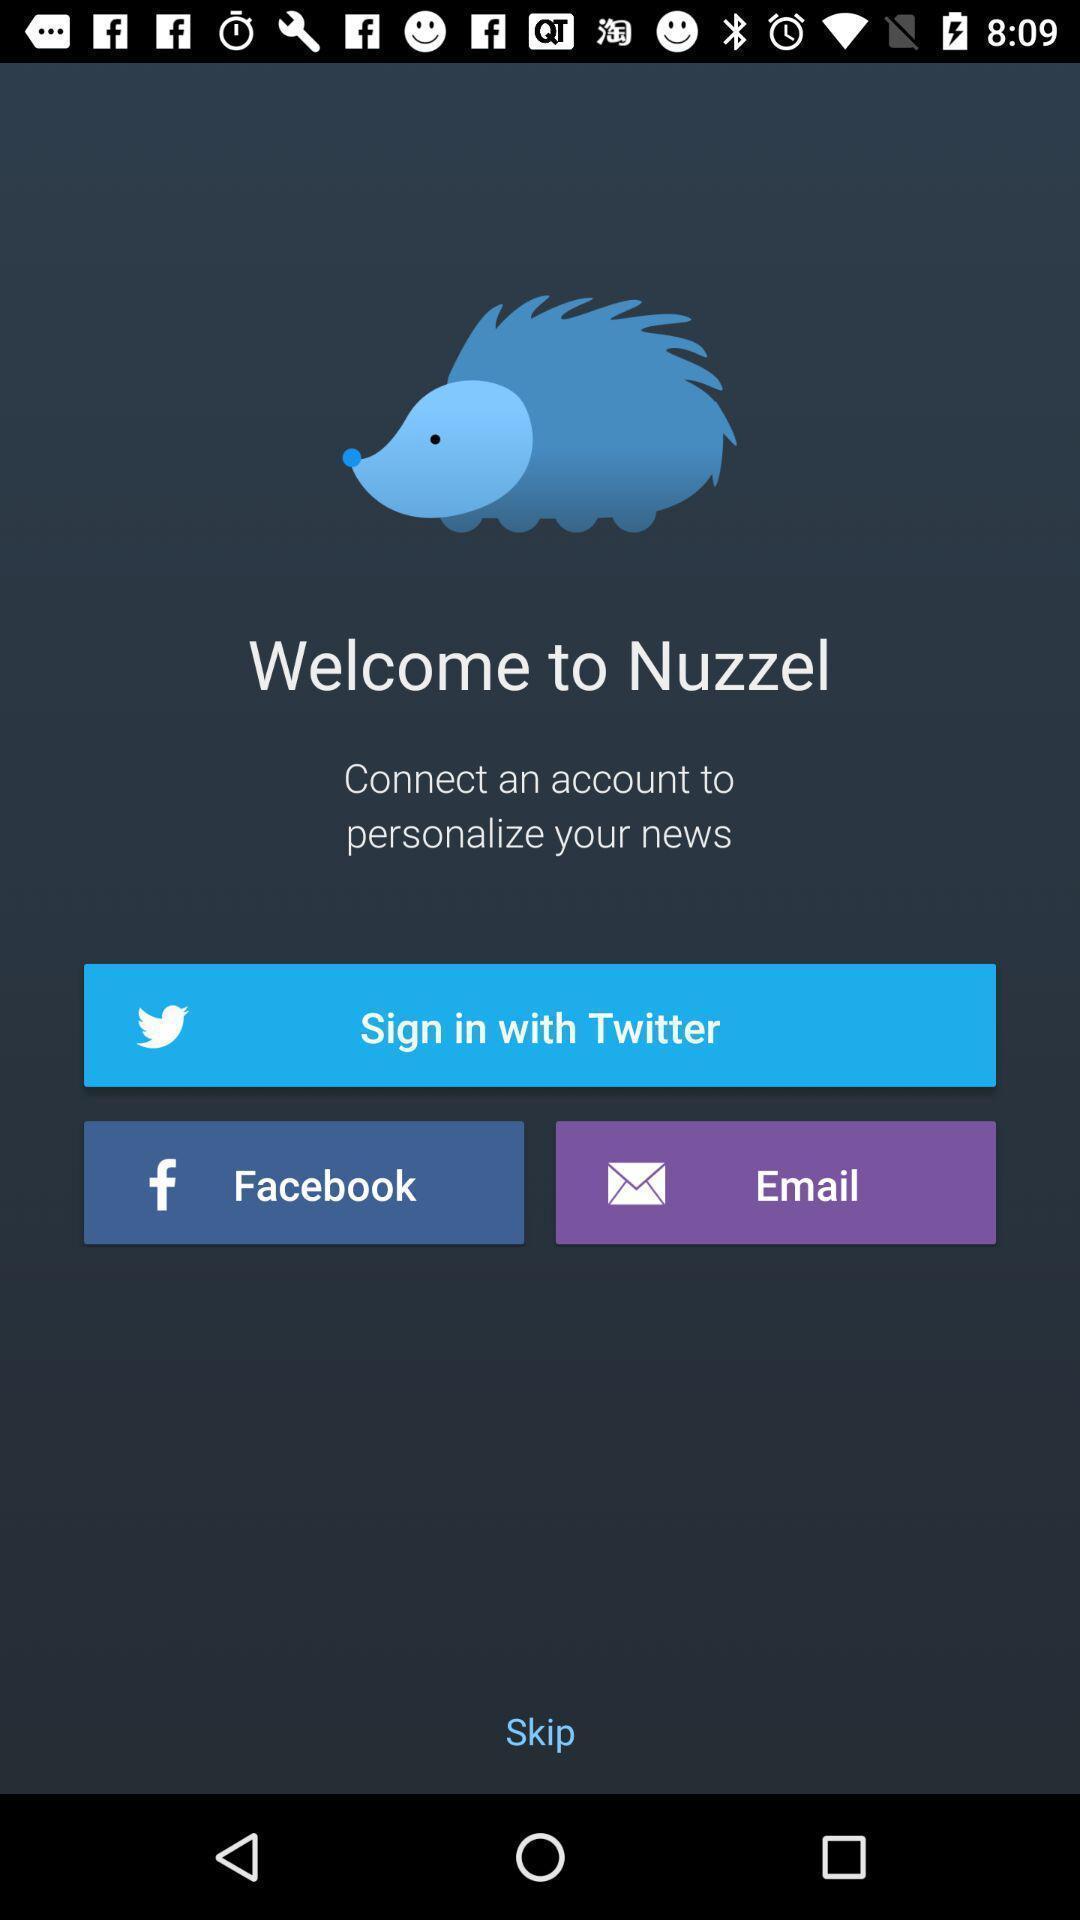Please provide a description for this image. Welcome page of news app to sign-in with social app. 